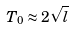Convert formula to latex. <formula><loc_0><loc_0><loc_500><loc_500>T _ { 0 } \approx 2 \sqrt { l }</formula> 